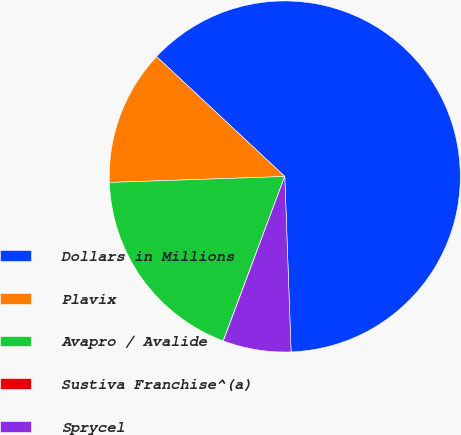<chart> <loc_0><loc_0><loc_500><loc_500><pie_chart><fcel>Dollars in Millions<fcel>Plavix<fcel>Avapro / Avalide<fcel>Sustiva Franchise^(a)<fcel>Sprycel<nl><fcel>62.46%<fcel>12.51%<fcel>18.75%<fcel>0.02%<fcel>6.26%<nl></chart> 